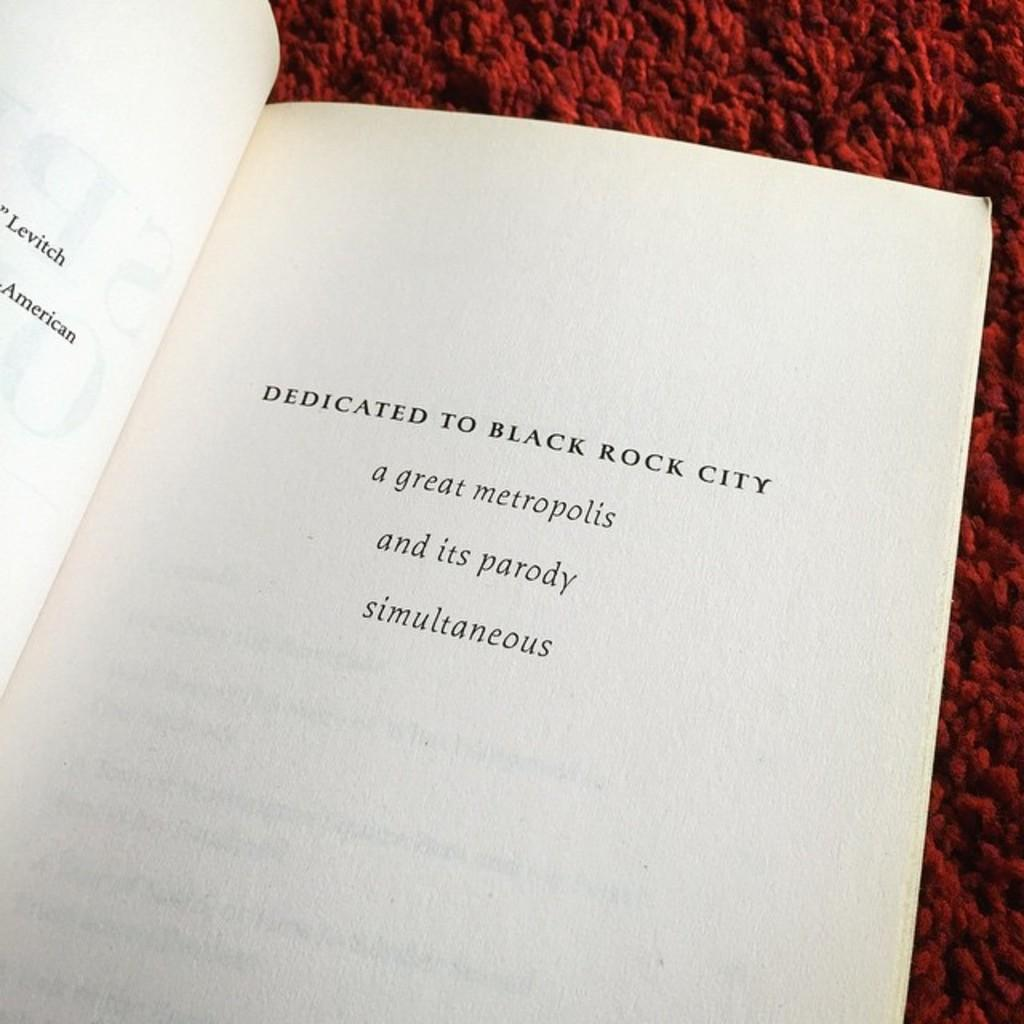<image>
Describe the image concisely. a book that has the word dedicated on it 